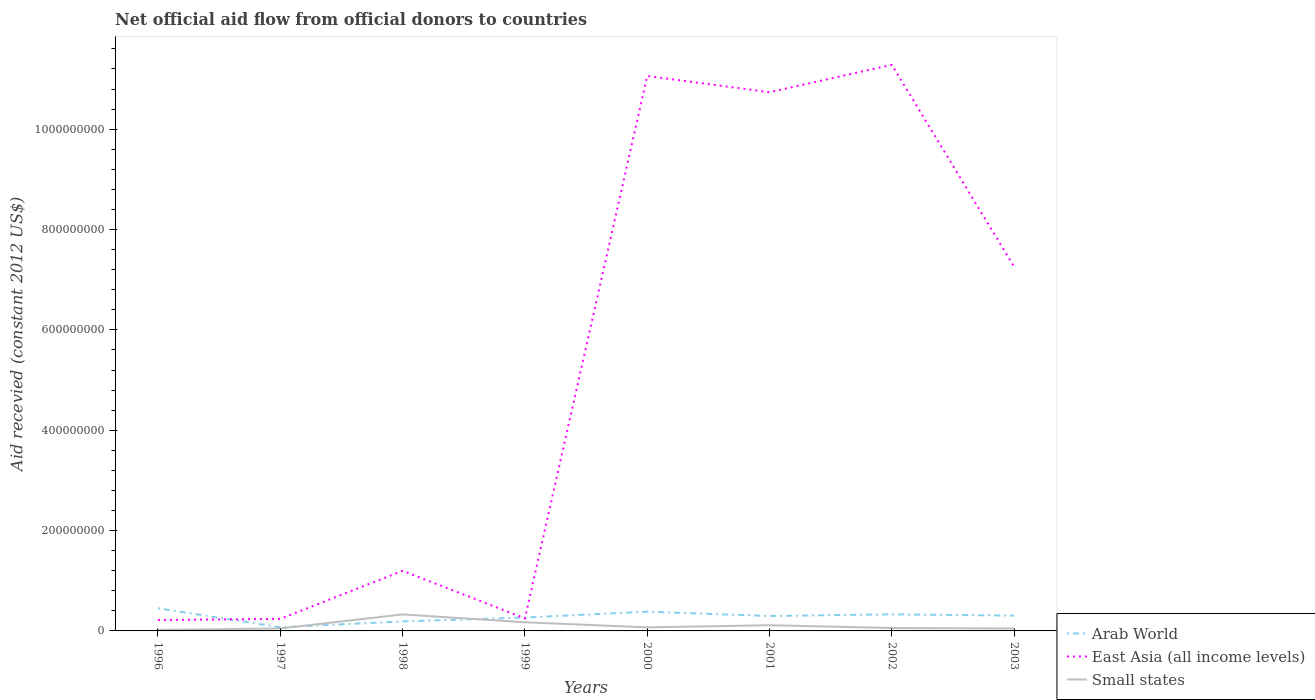How many different coloured lines are there?
Provide a short and direct response. 3. Is the number of lines equal to the number of legend labels?
Provide a short and direct response. Yes. Across all years, what is the maximum total aid received in Small states?
Provide a short and direct response. 2.04e+06. What is the total total aid received in Small states in the graph?
Provide a short and direct response. -2.89e+06. What is the difference between the highest and the second highest total aid received in Small states?
Your answer should be very brief. 3.09e+07. What is the difference between two consecutive major ticks on the Y-axis?
Your response must be concise. 2.00e+08. Are the values on the major ticks of Y-axis written in scientific E-notation?
Keep it short and to the point. No. Where does the legend appear in the graph?
Offer a very short reply. Bottom right. How many legend labels are there?
Offer a terse response. 3. How are the legend labels stacked?
Make the answer very short. Vertical. What is the title of the graph?
Make the answer very short. Net official aid flow from official donors to countries. What is the label or title of the Y-axis?
Provide a succinct answer. Aid recevied (constant 2012 US$). What is the Aid recevied (constant 2012 US$) in Arab World in 1996?
Provide a succinct answer. 4.51e+07. What is the Aid recevied (constant 2012 US$) in East Asia (all income levels) in 1996?
Provide a succinct answer. 2.17e+07. What is the Aid recevied (constant 2012 US$) of Small states in 1996?
Offer a very short reply. 2.04e+06. What is the Aid recevied (constant 2012 US$) of Arab World in 1997?
Offer a terse response. 7.29e+06. What is the Aid recevied (constant 2012 US$) in East Asia (all income levels) in 1997?
Provide a short and direct response. 2.41e+07. What is the Aid recevied (constant 2012 US$) of Small states in 1997?
Offer a terse response. 4.93e+06. What is the Aid recevied (constant 2012 US$) of Arab World in 1998?
Provide a short and direct response. 1.90e+07. What is the Aid recevied (constant 2012 US$) of East Asia (all income levels) in 1998?
Give a very brief answer. 1.20e+08. What is the Aid recevied (constant 2012 US$) in Small states in 1998?
Give a very brief answer. 3.29e+07. What is the Aid recevied (constant 2012 US$) of Arab World in 1999?
Your answer should be compact. 2.67e+07. What is the Aid recevied (constant 2012 US$) in East Asia (all income levels) in 1999?
Offer a terse response. 2.50e+07. What is the Aid recevied (constant 2012 US$) in Small states in 1999?
Provide a succinct answer. 1.72e+07. What is the Aid recevied (constant 2012 US$) of Arab World in 2000?
Offer a very short reply. 3.84e+07. What is the Aid recevied (constant 2012 US$) in East Asia (all income levels) in 2000?
Provide a succinct answer. 1.11e+09. What is the Aid recevied (constant 2012 US$) of Small states in 2000?
Make the answer very short. 7.08e+06. What is the Aid recevied (constant 2012 US$) in Arab World in 2001?
Your answer should be very brief. 2.97e+07. What is the Aid recevied (constant 2012 US$) in East Asia (all income levels) in 2001?
Your answer should be very brief. 1.07e+09. What is the Aid recevied (constant 2012 US$) of Small states in 2001?
Keep it short and to the point. 1.14e+07. What is the Aid recevied (constant 2012 US$) in Arab World in 2002?
Ensure brevity in your answer.  3.30e+07. What is the Aid recevied (constant 2012 US$) of East Asia (all income levels) in 2002?
Provide a short and direct response. 1.13e+09. What is the Aid recevied (constant 2012 US$) in Small states in 2002?
Provide a succinct answer. 5.78e+06. What is the Aid recevied (constant 2012 US$) in Arab World in 2003?
Ensure brevity in your answer.  3.05e+07. What is the Aid recevied (constant 2012 US$) in East Asia (all income levels) in 2003?
Keep it short and to the point. 7.26e+08. What is the Aid recevied (constant 2012 US$) in Small states in 2003?
Make the answer very short. 4.76e+06. Across all years, what is the maximum Aid recevied (constant 2012 US$) of Arab World?
Make the answer very short. 4.51e+07. Across all years, what is the maximum Aid recevied (constant 2012 US$) of East Asia (all income levels)?
Your response must be concise. 1.13e+09. Across all years, what is the maximum Aid recevied (constant 2012 US$) in Small states?
Give a very brief answer. 3.29e+07. Across all years, what is the minimum Aid recevied (constant 2012 US$) of Arab World?
Your answer should be compact. 7.29e+06. Across all years, what is the minimum Aid recevied (constant 2012 US$) in East Asia (all income levels)?
Your answer should be compact. 2.17e+07. Across all years, what is the minimum Aid recevied (constant 2012 US$) of Small states?
Keep it short and to the point. 2.04e+06. What is the total Aid recevied (constant 2012 US$) in Arab World in the graph?
Offer a very short reply. 2.30e+08. What is the total Aid recevied (constant 2012 US$) in East Asia (all income levels) in the graph?
Provide a succinct answer. 4.22e+09. What is the total Aid recevied (constant 2012 US$) in Small states in the graph?
Ensure brevity in your answer.  8.61e+07. What is the difference between the Aid recevied (constant 2012 US$) in Arab World in 1996 and that in 1997?
Offer a very short reply. 3.78e+07. What is the difference between the Aid recevied (constant 2012 US$) in East Asia (all income levels) in 1996 and that in 1997?
Your response must be concise. -2.39e+06. What is the difference between the Aid recevied (constant 2012 US$) of Small states in 1996 and that in 1997?
Provide a succinct answer. -2.89e+06. What is the difference between the Aid recevied (constant 2012 US$) in Arab World in 1996 and that in 1998?
Offer a terse response. 2.62e+07. What is the difference between the Aid recevied (constant 2012 US$) in East Asia (all income levels) in 1996 and that in 1998?
Offer a terse response. -9.81e+07. What is the difference between the Aid recevied (constant 2012 US$) in Small states in 1996 and that in 1998?
Give a very brief answer. -3.09e+07. What is the difference between the Aid recevied (constant 2012 US$) in Arab World in 1996 and that in 1999?
Offer a terse response. 1.85e+07. What is the difference between the Aid recevied (constant 2012 US$) of East Asia (all income levels) in 1996 and that in 1999?
Ensure brevity in your answer.  -3.34e+06. What is the difference between the Aid recevied (constant 2012 US$) in Small states in 1996 and that in 1999?
Your response must be concise. -1.52e+07. What is the difference between the Aid recevied (constant 2012 US$) in Arab World in 1996 and that in 2000?
Your answer should be very brief. 6.77e+06. What is the difference between the Aid recevied (constant 2012 US$) in East Asia (all income levels) in 1996 and that in 2000?
Your answer should be compact. -1.08e+09. What is the difference between the Aid recevied (constant 2012 US$) of Small states in 1996 and that in 2000?
Offer a terse response. -5.04e+06. What is the difference between the Aid recevied (constant 2012 US$) of Arab World in 1996 and that in 2001?
Provide a short and direct response. 1.54e+07. What is the difference between the Aid recevied (constant 2012 US$) of East Asia (all income levels) in 1996 and that in 2001?
Provide a succinct answer. -1.05e+09. What is the difference between the Aid recevied (constant 2012 US$) of Small states in 1996 and that in 2001?
Make the answer very short. -9.34e+06. What is the difference between the Aid recevied (constant 2012 US$) of Arab World in 1996 and that in 2002?
Make the answer very short. 1.21e+07. What is the difference between the Aid recevied (constant 2012 US$) of East Asia (all income levels) in 1996 and that in 2002?
Your response must be concise. -1.11e+09. What is the difference between the Aid recevied (constant 2012 US$) of Small states in 1996 and that in 2002?
Your answer should be compact. -3.74e+06. What is the difference between the Aid recevied (constant 2012 US$) in Arab World in 1996 and that in 2003?
Your answer should be compact. 1.46e+07. What is the difference between the Aid recevied (constant 2012 US$) in East Asia (all income levels) in 1996 and that in 2003?
Provide a short and direct response. -7.04e+08. What is the difference between the Aid recevied (constant 2012 US$) of Small states in 1996 and that in 2003?
Make the answer very short. -2.72e+06. What is the difference between the Aid recevied (constant 2012 US$) of Arab World in 1997 and that in 1998?
Offer a very short reply. -1.17e+07. What is the difference between the Aid recevied (constant 2012 US$) in East Asia (all income levels) in 1997 and that in 1998?
Make the answer very short. -9.57e+07. What is the difference between the Aid recevied (constant 2012 US$) in Small states in 1997 and that in 1998?
Keep it short and to the point. -2.80e+07. What is the difference between the Aid recevied (constant 2012 US$) of Arab World in 1997 and that in 1999?
Give a very brief answer. -1.94e+07. What is the difference between the Aid recevied (constant 2012 US$) in East Asia (all income levels) in 1997 and that in 1999?
Provide a succinct answer. -9.50e+05. What is the difference between the Aid recevied (constant 2012 US$) of Small states in 1997 and that in 1999?
Your answer should be very brief. -1.23e+07. What is the difference between the Aid recevied (constant 2012 US$) of Arab World in 1997 and that in 2000?
Keep it short and to the point. -3.11e+07. What is the difference between the Aid recevied (constant 2012 US$) of East Asia (all income levels) in 1997 and that in 2000?
Offer a terse response. -1.08e+09. What is the difference between the Aid recevied (constant 2012 US$) in Small states in 1997 and that in 2000?
Provide a succinct answer. -2.15e+06. What is the difference between the Aid recevied (constant 2012 US$) in Arab World in 1997 and that in 2001?
Offer a terse response. -2.24e+07. What is the difference between the Aid recevied (constant 2012 US$) in East Asia (all income levels) in 1997 and that in 2001?
Ensure brevity in your answer.  -1.05e+09. What is the difference between the Aid recevied (constant 2012 US$) of Small states in 1997 and that in 2001?
Offer a terse response. -6.45e+06. What is the difference between the Aid recevied (constant 2012 US$) of Arab World in 1997 and that in 2002?
Ensure brevity in your answer.  -2.58e+07. What is the difference between the Aid recevied (constant 2012 US$) in East Asia (all income levels) in 1997 and that in 2002?
Provide a succinct answer. -1.10e+09. What is the difference between the Aid recevied (constant 2012 US$) of Small states in 1997 and that in 2002?
Provide a succinct answer. -8.50e+05. What is the difference between the Aid recevied (constant 2012 US$) in Arab World in 1997 and that in 2003?
Ensure brevity in your answer.  -2.32e+07. What is the difference between the Aid recevied (constant 2012 US$) in East Asia (all income levels) in 1997 and that in 2003?
Offer a terse response. -7.02e+08. What is the difference between the Aid recevied (constant 2012 US$) in Arab World in 1998 and that in 1999?
Provide a short and direct response. -7.71e+06. What is the difference between the Aid recevied (constant 2012 US$) in East Asia (all income levels) in 1998 and that in 1999?
Provide a short and direct response. 9.48e+07. What is the difference between the Aid recevied (constant 2012 US$) in Small states in 1998 and that in 1999?
Offer a terse response. 1.57e+07. What is the difference between the Aid recevied (constant 2012 US$) in Arab World in 1998 and that in 2000?
Make the answer very short. -1.94e+07. What is the difference between the Aid recevied (constant 2012 US$) of East Asia (all income levels) in 1998 and that in 2000?
Provide a short and direct response. -9.86e+08. What is the difference between the Aid recevied (constant 2012 US$) of Small states in 1998 and that in 2000?
Your response must be concise. 2.58e+07. What is the difference between the Aid recevied (constant 2012 US$) of Arab World in 1998 and that in 2001?
Provide a short and direct response. -1.07e+07. What is the difference between the Aid recevied (constant 2012 US$) of East Asia (all income levels) in 1998 and that in 2001?
Give a very brief answer. -9.54e+08. What is the difference between the Aid recevied (constant 2012 US$) of Small states in 1998 and that in 2001?
Keep it short and to the point. 2.15e+07. What is the difference between the Aid recevied (constant 2012 US$) of Arab World in 1998 and that in 2002?
Provide a short and direct response. -1.41e+07. What is the difference between the Aid recevied (constant 2012 US$) of East Asia (all income levels) in 1998 and that in 2002?
Provide a succinct answer. -1.01e+09. What is the difference between the Aid recevied (constant 2012 US$) in Small states in 1998 and that in 2002?
Your answer should be very brief. 2.71e+07. What is the difference between the Aid recevied (constant 2012 US$) of Arab World in 1998 and that in 2003?
Make the answer very short. -1.15e+07. What is the difference between the Aid recevied (constant 2012 US$) of East Asia (all income levels) in 1998 and that in 2003?
Offer a very short reply. -6.06e+08. What is the difference between the Aid recevied (constant 2012 US$) of Small states in 1998 and that in 2003?
Your response must be concise. 2.81e+07. What is the difference between the Aid recevied (constant 2012 US$) of Arab World in 1999 and that in 2000?
Offer a very short reply. -1.17e+07. What is the difference between the Aid recevied (constant 2012 US$) in East Asia (all income levels) in 1999 and that in 2000?
Your response must be concise. -1.08e+09. What is the difference between the Aid recevied (constant 2012 US$) of Small states in 1999 and that in 2000?
Offer a very short reply. 1.02e+07. What is the difference between the Aid recevied (constant 2012 US$) in Arab World in 1999 and that in 2001?
Make the answer very short. -3.03e+06. What is the difference between the Aid recevied (constant 2012 US$) of East Asia (all income levels) in 1999 and that in 2001?
Provide a short and direct response. -1.05e+09. What is the difference between the Aid recevied (constant 2012 US$) in Small states in 1999 and that in 2001?
Give a very brief answer. 5.86e+06. What is the difference between the Aid recevied (constant 2012 US$) in Arab World in 1999 and that in 2002?
Make the answer very short. -6.38e+06. What is the difference between the Aid recevied (constant 2012 US$) in East Asia (all income levels) in 1999 and that in 2002?
Offer a terse response. -1.10e+09. What is the difference between the Aid recevied (constant 2012 US$) of Small states in 1999 and that in 2002?
Provide a short and direct response. 1.15e+07. What is the difference between the Aid recevied (constant 2012 US$) of Arab World in 1999 and that in 2003?
Your answer should be very brief. -3.83e+06. What is the difference between the Aid recevied (constant 2012 US$) in East Asia (all income levels) in 1999 and that in 2003?
Provide a succinct answer. -7.01e+08. What is the difference between the Aid recevied (constant 2012 US$) of Small states in 1999 and that in 2003?
Keep it short and to the point. 1.25e+07. What is the difference between the Aid recevied (constant 2012 US$) in Arab World in 2000 and that in 2001?
Give a very brief answer. 8.66e+06. What is the difference between the Aid recevied (constant 2012 US$) in East Asia (all income levels) in 2000 and that in 2001?
Make the answer very short. 3.23e+07. What is the difference between the Aid recevied (constant 2012 US$) in Small states in 2000 and that in 2001?
Your response must be concise. -4.30e+06. What is the difference between the Aid recevied (constant 2012 US$) in Arab World in 2000 and that in 2002?
Your answer should be compact. 5.31e+06. What is the difference between the Aid recevied (constant 2012 US$) in East Asia (all income levels) in 2000 and that in 2002?
Give a very brief answer. -2.23e+07. What is the difference between the Aid recevied (constant 2012 US$) in Small states in 2000 and that in 2002?
Offer a terse response. 1.30e+06. What is the difference between the Aid recevied (constant 2012 US$) in Arab World in 2000 and that in 2003?
Your response must be concise. 7.86e+06. What is the difference between the Aid recevied (constant 2012 US$) of East Asia (all income levels) in 2000 and that in 2003?
Make the answer very short. 3.80e+08. What is the difference between the Aid recevied (constant 2012 US$) of Small states in 2000 and that in 2003?
Provide a succinct answer. 2.32e+06. What is the difference between the Aid recevied (constant 2012 US$) in Arab World in 2001 and that in 2002?
Offer a very short reply. -3.35e+06. What is the difference between the Aid recevied (constant 2012 US$) in East Asia (all income levels) in 2001 and that in 2002?
Provide a succinct answer. -5.46e+07. What is the difference between the Aid recevied (constant 2012 US$) in Small states in 2001 and that in 2002?
Your answer should be compact. 5.60e+06. What is the difference between the Aid recevied (constant 2012 US$) in Arab World in 2001 and that in 2003?
Give a very brief answer. -8.00e+05. What is the difference between the Aid recevied (constant 2012 US$) in East Asia (all income levels) in 2001 and that in 2003?
Offer a very short reply. 3.48e+08. What is the difference between the Aid recevied (constant 2012 US$) in Small states in 2001 and that in 2003?
Keep it short and to the point. 6.62e+06. What is the difference between the Aid recevied (constant 2012 US$) in Arab World in 2002 and that in 2003?
Keep it short and to the point. 2.55e+06. What is the difference between the Aid recevied (constant 2012 US$) of East Asia (all income levels) in 2002 and that in 2003?
Keep it short and to the point. 4.02e+08. What is the difference between the Aid recevied (constant 2012 US$) in Small states in 2002 and that in 2003?
Your response must be concise. 1.02e+06. What is the difference between the Aid recevied (constant 2012 US$) of Arab World in 1996 and the Aid recevied (constant 2012 US$) of East Asia (all income levels) in 1997?
Your answer should be very brief. 2.10e+07. What is the difference between the Aid recevied (constant 2012 US$) in Arab World in 1996 and the Aid recevied (constant 2012 US$) in Small states in 1997?
Offer a very short reply. 4.02e+07. What is the difference between the Aid recevied (constant 2012 US$) in East Asia (all income levels) in 1996 and the Aid recevied (constant 2012 US$) in Small states in 1997?
Your answer should be very brief. 1.68e+07. What is the difference between the Aid recevied (constant 2012 US$) in Arab World in 1996 and the Aid recevied (constant 2012 US$) in East Asia (all income levels) in 1998?
Offer a terse response. -7.46e+07. What is the difference between the Aid recevied (constant 2012 US$) of Arab World in 1996 and the Aid recevied (constant 2012 US$) of Small states in 1998?
Ensure brevity in your answer.  1.22e+07. What is the difference between the Aid recevied (constant 2012 US$) in East Asia (all income levels) in 1996 and the Aid recevied (constant 2012 US$) in Small states in 1998?
Offer a very short reply. -1.12e+07. What is the difference between the Aid recevied (constant 2012 US$) of Arab World in 1996 and the Aid recevied (constant 2012 US$) of East Asia (all income levels) in 1999?
Your answer should be compact. 2.01e+07. What is the difference between the Aid recevied (constant 2012 US$) of Arab World in 1996 and the Aid recevied (constant 2012 US$) of Small states in 1999?
Give a very brief answer. 2.79e+07. What is the difference between the Aid recevied (constant 2012 US$) of East Asia (all income levels) in 1996 and the Aid recevied (constant 2012 US$) of Small states in 1999?
Your response must be concise. 4.45e+06. What is the difference between the Aid recevied (constant 2012 US$) in Arab World in 1996 and the Aid recevied (constant 2012 US$) in East Asia (all income levels) in 2000?
Keep it short and to the point. -1.06e+09. What is the difference between the Aid recevied (constant 2012 US$) of Arab World in 1996 and the Aid recevied (constant 2012 US$) of Small states in 2000?
Ensure brevity in your answer.  3.80e+07. What is the difference between the Aid recevied (constant 2012 US$) in East Asia (all income levels) in 1996 and the Aid recevied (constant 2012 US$) in Small states in 2000?
Make the answer very short. 1.46e+07. What is the difference between the Aid recevied (constant 2012 US$) of Arab World in 1996 and the Aid recevied (constant 2012 US$) of East Asia (all income levels) in 2001?
Ensure brevity in your answer.  -1.03e+09. What is the difference between the Aid recevied (constant 2012 US$) in Arab World in 1996 and the Aid recevied (constant 2012 US$) in Small states in 2001?
Give a very brief answer. 3.38e+07. What is the difference between the Aid recevied (constant 2012 US$) in East Asia (all income levels) in 1996 and the Aid recevied (constant 2012 US$) in Small states in 2001?
Your answer should be compact. 1.03e+07. What is the difference between the Aid recevied (constant 2012 US$) in Arab World in 1996 and the Aid recevied (constant 2012 US$) in East Asia (all income levels) in 2002?
Keep it short and to the point. -1.08e+09. What is the difference between the Aid recevied (constant 2012 US$) in Arab World in 1996 and the Aid recevied (constant 2012 US$) in Small states in 2002?
Your answer should be very brief. 3.94e+07. What is the difference between the Aid recevied (constant 2012 US$) of East Asia (all income levels) in 1996 and the Aid recevied (constant 2012 US$) of Small states in 2002?
Give a very brief answer. 1.59e+07. What is the difference between the Aid recevied (constant 2012 US$) of Arab World in 1996 and the Aid recevied (constant 2012 US$) of East Asia (all income levels) in 2003?
Ensure brevity in your answer.  -6.81e+08. What is the difference between the Aid recevied (constant 2012 US$) in Arab World in 1996 and the Aid recevied (constant 2012 US$) in Small states in 2003?
Keep it short and to the point. 4.04e+07. What is the difference between the Aid recevied (constant 2012 US$) in East Asia (all income levels) in 1996 and the Aid recevied (constant 2012 US$) in Small states in 2003?
Your answer should be compact. 1.69e+07. What is the difference between the Aid recevied (constant 2012 US$) in Arab World in 1997 and the Aid recevied (constant 2012 US$) in East Asia (all income levels) in 1998?
Your answer should be very brief. -1.12e+08. What is the difference between the Aid recevied (constant 2012 US$) in Arab World in 1997 and the Aid recevied (constant 2012 US$) in Small states in 1998?
Your response must be concise. -2.56e+07. What is the difference between the Aid recevied (constant 2012 US$) of East Asia (all income levels) in 1997 and the Aid recevied (constant 2012 US$) of Small states in 1998?
Provide a short and direct response. -8.82e+06. What is the difference between the Aid recevied (constant 2012 US$) of Arab World in 1997 and the Aid recevied (constant 2012 US$) of East Asia (all income levels) in 1999?
Keep it short and to the point. -1.77e+07. What is the difference between the Aid recevied (constant 2012 US$) of Arab World in 1997 and the Aid recevied (constant 2012 US$) of Small states in 1999?
Your answer should be compact. -9.95e+06. What is the difference between the Aid recevied (constant 2012 US$) in East Asia (all income levels) in 1997 and the Aid recevied (constant 2012 US$) in Small states in 1999?
Ensure brevity in your answer.  6.84e+06. What is the difference between the Aid recevied (constant 2012 US$) in Arab World in 1997 and the Aid recevied (constant 2012 US$) in East Asia (all income levels) in 2000?
Provide a succinct answer. -1.10e+09. What is the difference between the Aid recevied (constant 2012 US$) in East Asia (all income levels) in 1997 and the Aid recevied (constant 2012 US$) in Small states in 2000?
Your answer should be compact. 1.70e+07. What is the difference between the Aid recevied (constant 2012 US$) in Arab World in 1997 and the Aid recevied (constant 2012 US$) in East Asia (all income levels) in 2001?
Your answer should be very brief. -1.07e+09. What is the difference between the Aid recevied (constant 2012 US$) in Arab World in 1997 and the Aid recevied (constant 2012 US$) in Small states in 2001?
Your answer should be very brief. -4.09e+06. What is the difference between the Aid recevied (constant 2012 US$) in East Asia (all income levels) in 1997 and the Aid recevied (constant 2012 US$) in Small states in 2001?
Your answer should be very brief. 1.27e+07. What is the difference between the Aid recevied (constant 2012 US$) of Arab World in 1997 and the Aid recevied (constant 2012 US$) of East Asia (all income levels) in 2002?
Offer a very short reply. -1.12e+09. What is the difference between the Aid recevied (constant 2012 US$) of Arab World in 1997 and the Aid recevied (constant 2012 US$) of Small states in 2002?
Your answer should be compact. 1.51e+06. What is the difference between the Aid recevied (constant 2012 US$) in East Asia (all income levels) in 1997 and the Aid recevied (constant 2012 US$) in Small states in 2002?
Provide a short and direct response. 1.83e+07. What is the difference between the Aid recevied (constant 2012 US$) in Arab World in 1997 and the Aid recevied (constant 2012 US$) in East Asia (all income levels) in 2003?
Keep it short and to the point. -7.18e+08. What is the difference between the Aid recevied (constant 2012 US$) in Arab World in 1997 and the Aid recevied (constant 2012 US$) in Small states in 2003?
Your response must be concise. 2.53e+06. What is the difference between the Aid recevied (constant 2012 US$) in East Asia (all income levels) in 1997 and the Aid recevied (constant 2012 US$) in Small states in 2003?
Provide a succinct answer. 1.93e+07. What is the difference between the Aid recevied (constant 2012 US$) in Arab World in 1998 and the Aid recevied (constant 2012 US$) in East Asia (all income levels) in 1999?
Offer a very short reply. -6.07e+06. What is the difference between the Aid recevied (constant 2012 US$) in Arab World in 1998 and the Aid recevied (constant 2012 US$) in Small states in 1999?
Give a very brief answer. 1.72e+06. What is the difference between the Aid recevied (constant 2012 US$) in East Asia (all income levels) in 1998 and the Aid recevied (constant 2012 US$) in Small states in 1999?
Give a very brief answer. 1.03e+08. What is the difference between the Aid recevied (constant 2012 US$) of Arab World in 1998 and the Aid recevied (constant 2012 US$) of East Asia (all income levels) in 2000?
Offer a very short reply. -1.09e+09. What is the difference between the Aid recevied (constant 2012 US$) in Arab World in 1998 and the Aid recevied (constant 2012 US$) in Small states in 2000?
Your answer should be compact. 1.19e+07. What is the difference between the Aid recevied (constant 2012 US$) in East Asia (all income levels) in 1998 and the Aid recevied (constant 2012 US$) in Small states in 2000?
Offer a very short reply. 1.13e+08. What is the difference between the Aid recevied (constant 2012 US$) in Arab World in 1998 and the Aid recevied (constant 2012 US$) in East Asia (all income levels) in 2001?
Make the answer very short. -1.05e+09. What is the difference between the Aid recevied (constant 2012 US$) of Arab World in 1998 and the Aid recevied (constant 2012 US$) of Small states in 2001?
Your answer should be compact. 7.58e+06. What is the difference between the Aid recevied (constant 2012 US$) in East Asia (all income levels) in 1998 and the Aid recevied (constant 2012 US$) in Small states in 2001?
Offer a very short reply. 1.08e+08. What is the difference between the Aid recevied (constant 2012 US$) of Arab World in 1998 and the Aid recevied (constant 2012 US$) of East Asia (all income levels) in 2002?
Make the answer very short. -1.11e+09. What is the difference between the Aid recevied (constant 2012 US$) in Arab World in 1998 and the Aid recevied (constant 2012 US$) in Small states in 2002?
Ensure brevity in your answer.  1.32e+07. What is the difference between the Aid recevied (constant 2012 US$) of East Asia (all income levels) in 1998 and the Aid recevied (constant 2012 US$) of Small states in 2002?
Ensure brevity in your answer.  1.14e+08. What is the difference between the Aid recevied (constant 2012 US$) of Arab World in 1998 and the Aid recevied (constant 2012 US$) of East Asia (all income levels) in 2003?
Your answer should be very brief. -7.07e+08. What is the difference between the Aid recevied (constant 2012 US$) in Arab World in 1998 and the Aid recevied (constant 2012 US$) in Small states in 2003?
Make the answer very short. 1.42e+07. What is the difference between the Aid recevied (constant 2012 US$) in East Asia (all income levels) in 1998 and the Aid recevied (constant 2012 US$) in Small states in 2003?
Provide a succinct answer. 1.15e+08. What is the difference between the Aid recevied (constant 2012 US$) of Arab World in 1999 and the Aid recevied (constant 2012 US$) of East Asia (all income levels) in 2000?
Make the answer very short. -1.08e+09. What is the difference between the Aid recevied (constant 2012 US$) in Arab World in 1999 and the Aid recevied (constant 2012 US$) in Small states in 2000?
Keep it short and to the point. 1.96e+07. What is the difference between the Aid recevied (constant 2012 US$) in East Asia (all income levels) in 1999 and the Aid recevied (constant 2012 US$) in Small states in 2000?
Provide a succinct answer. 1.80e+07. What is the difference between the Aid recevied (constant 2012 US$) in Arab World in 1999 and the Aid recevied (constant 2012 US$) in East Asia (all income levels) in 2001?
Provide a succinct answer. -1.05e+09. What is the difference between the Aid recevied (constant 2012 US$) of Arab World in 1999 and the Aid recevied (constant 2012 US$) of Small states in 2001?
Provide a short and direct response. 1.53e+07. What is the difference between the Aid recevied (constant 2012 US$) in East Asia (all income levels) in 1999 and the Aid recevied (constant 2012 US$) in Small states in 2001?
Ensure brevity in your answer.  1.36e+07. What is the difference between the Aid recevied (constant 2012 US$) in Arab World in 1999 and the Aid recevied (constant 2012 US$) in East Asia (all income levels) in 2002?
Ensure brevity in your answer.  -1.10e+09. What is the difference between the Aid recevied (constant 2012 US$) of Arab World in 1999 and the Aid recevied (constant 2012 US$) of Small states in 2002?
Keep it short and to the point. 2.09e+07. What is the difference between the Aid recevied (constant 2012 US$) of East Asia (all income levels) in 1999 and the Aid recevied (constant 2012 US$) of Small states in 2002?
Offer a very short reply. 1.92e+07. What is the difference between the Aid recevied (constant 2012 US$) in Arab World in 1999 and the Aid recevied (constant 2012 US$) in East Asia (all income levels) in 2003?
Make the answer very short. -6.99e+08. What is the difference between the Aid recevied (constant 2012 US$) of Arab World in 1999 and the Aid recevied (constant 2012 US$) of Small states in 2003?
Provide a succinct answer. 2.19e+07. What is the difference between the Aid recevied (constant 2012 US$) in East Asia (all income levels) in 1999 and the Aid recevied (constant 2012 US$) in Small states in 2003?
Provide a succinct answer. 2.03e+07. What is the difference between the Aid recevied (constant 2012 US$) of Arab World in 2000 and the Aid recevied (constant 2012 US$) of East Asia (all income levels) in 2001?
Your answer should be very brief. -1.04e+09. What is the difference between the Aid recevied (constant 2012 US$) of Arab World in 2000 and the Aid recevied (constant 2012 US$) of Small states in 2001?
Provide a succinct answer. 2.70e+07. What is the difference between the Aid recevied (constant 2012 US$) of East Asia (all income levels) in 2000 and the Aid recevied (constant 2012 US$) of Small states in 2001?
Keep it short and to the point. 1.09e+09. What is the difference between the Aid recevied (constant 2012 US$) of Arab World in 2000 and the Aid recevied (constant 2012 US$) of East Asia (all income levels) in 2002?
Make the answer very short. -1.09e+09. What is the difference between the Aid recevied (constant 2012 US$) in Arab World in 2000 and the Aid recevied (constant 2012 US$) in Small states in 2002?
Your answer should be compact. 3.26e+07. What is the difference between the Aid recevied (constant 2012 US$) in East Asia (all income levels) in 2000 and the Aid recevied (constant 2012 US$) in Small states in 2002?
Keep it short and to the point. 1.10e+09. What is the difference between the Aid recevied (constant 2012 US$) of Arab World in 2000 and the Aid recevied (constant 2012 US$) of East Asia (all income levels) in 2003?
Provide a succinct answer. -6.87e+08. What is the difference between the Aid recevied (constant 2012 US$) in Arab World in 2000 and the Aid recevied (constant 2012 US$) in Small states in 2003?
Give a very brief answer. 3.36e+07. What is the difference between the Aid recevied (constant 2012 US$) of East Asia (all income levels) in 2000 and the Aid recevied (constant 2012 US$) of Small states in 2003?
Provide a short and direct response. 1.10e+09. What is the difference between the Aid recevied (constant 2012 US$) of Arab World in 2001 and the Aid recevied (constant 2012 US$) of East Asia (all income levels) in 2002?
Provide a short and direct response. -1.10e+09. What is the difference between the Aid recevied (constant 2012 US$) of Arab World in 2001 and the Aid recevied (constant 2012 US$) of Small states in 2002?
Keep it short and to the point. 2.39e+07. What is the difference between the Aid recevied (constant 2012 US$) in East Asia (all income levels) in 2001 and the Aid recevied (constant 2012 US$) in Small states in 2002?
Your response must be concise. 1.07e+09. What is the difference between the Aid recevied (constant 2012 US$) of Arab World in 2001 and the Aid recevied (constant 2012 US$) of East Asia (all income levels) in 2003?
Your answer should be compact. -6.96e+08. What is the difference between the Aid recevied (constant 2012 US$) in Arab World in 2001 and the Aid recevied (constant 2012 US$) in Small states in 2003?
Provide a short and direct response. 2.49e+07. What is the difference between the Aid recevied (constant 2012 US$) of East Asia (all income levels) in 2001 and the Aid recevied (constant 2012 US$) of Small states in 2003?
Your answer should be very brief. 1.07e+09. What is the difference between the Aid recevied (constant 2012 US$) in Arab World in 2002 and the Aid recevied (constant 2012 US$) in East Asia (all income levels) in 2003?
Provide a succinct answer. -6.93e+08. What is the difference between the Aid recevied (constant 2012 US$) of Arab World in 2002 and the Aid recevied (constant 2012 US$) of Small states in 2003?
Your response must be concise. 2.83e+07. What is the difference between the Aid recevied (constant 2012 US$) in East Asia (all income levels) in 2002 and the Aid recevied (constant 2012 US$) in Small states in 2003?
Your answer should be compact. 1.12e+09. What is the average Aid recevied (constant 2012 US$) of Arab World per year?
Your answer should be compact. 2.87e+07. What is the average Aid recevied (constant 2012 US$) of East Asia (all income levels) per year?
Keep it short and to the point. 5.28e+08. What is the average Aid recevied (constant 2012 US$) of Small states per year?
Offer a very short reply. 1.08e+07. In the year 1996, what is the difference between the Aid recevied (constant 2012 US$) of Arab World and Aid recevied (constant 2012 US$) of East Asia (all income levels)?
Give a very brief answer. 2.34e+07. In the year 1996, what is the difference between the Aid recevied (constant 2012 US$) of Arab World and Aid recevied (constant 2012 US$) of Small states?
Offer a terse response. 4.31e+07. In the year 1996, what is the difference between the Aid recevied (constant 2012 US$) of East Asia (all income levels) and Aid recevied (constant 2012 US$) of Small states?
Provide a succinct answer. 1.96e+07. In the year 1997, what is the difference between the Aid recevied (constant 2012 US$) of Arab World and Aid recevied (constant 2012 US$) of East Asia (all income levels)?
Provide a short and direct response. -1.68e+07. In the year 1997, what is the difference between the Aid recevied (constant 2012 US$) in Arab World and Aid recevied (constant 2012 US$) in Small states?
Make the answer very short. 2.36e+06. In the year 1997, what is the difference between the Aid recevied (constant 2012 US$) of East Asia (all income levels) and Aid recevied (constant 2012 US$) of Small states?
Keep it short and to the point. 1.92e+07. In the year 1998, what is the difference between the Aid recevied (constant 2012 US$) in Arab World and Aid recevied (constant 2012 US$) in East Asia (all income levels)?
Your answer should be compact. -1.01e+08. In the year 1998, what is the difference between the Aid recevied (constant 2012 US$) of Arab World and Aid recevied (constant 2012 US$) of Small states?
Your answer should be very brief. -1.39e+07. In the year 1998, what is the difference between the Aid recevied (constant 2012 US$) of East Asia (all income levels) and Aid recevied (constant 2012 US$) of Small states?
Provide a succinct answer. 8.69e+07. In the year 1999, what is the difference between the Aid recevied (constant 2012 US$) of Arab World and Aid recevied (constant 2012 US$) of East Asia (all income levels)?
Offer a terse response. 1.64e+06. In the year 1999, what is the difference between the Aid recevied (constant 2012 US$) of Arab World and Aid recevied (constant 2012 US$) of Small states?
Your response must be concise. 9.43e+06. In the year 1999, what is the difference between the Aid recevied (constant 2012 US$) in East Asia (all income levels) and Aid recevied (constant 2012 US$) in Small states?
Give a very brief answer. 7.79e+06. In the year 2000, what is the difference between the Aid recevied (constant 2012 US$) of Arab World and Aid recevied (constant 2012 US$) of East Asia (all income levels)?
Offer a very short reply. -1.07e+09. In the year 2000, what is the difference between the Aid recevied (constant 2012 US$) of Arab World and Aid recevied (constant 2012 US$) of Small states?
Your response must be concise. 3.13e+07. In the year 2000, what is the difference between the Aid recevied (constant 2012 US$) of East Asia (all income levels) and Aid recevied (constant 2012 US$) of Small states?
Ensure brevity in your answer.  1.10e+09. In the year 2001, what is the difference between the Aid recevied (constant 2012 US$) of Arab World and Aid recevied (constant 2012 US$) of East Asia (all income levels)?
Keep it short and to the point. -1.04e+09. In the year 2001, what is the difference between the Aid recevied (constant 2012 US$) in Arab World and Aid recevied (constant 2012 US$) in Small states?
Provide a succinct answer. 1.83e+07. In the year 2001, what is the difference between the Aid recevied (constant 2012 US$) of East Asia (all income levels) and Aid recevied (constant 2012 US$) of Small states?
Offer a terse response. 1.06e+09. In the year 2002, what is the difference between the Aid recevied (constant 2012 US$) in Arab World and Aid recevied (constant 2012 US$) in East Asia (all income levels)?
Ensure brevity in your answer.  -1.10e+09. In the year 2002, what is the difference between the Aid recevied (constant 2012 US$) in Arab World and Aid recevied (constant 2012 US$) in Small states?
Offer a very short reply. 2.73e+07. In the year 2002, what is the difference between the Aid recevied (constant 2012 US$) in East Asia (all income levels) and Aid recevied (constant 2012 US$) in Small states?
Offer a very short reply. 1.12e+09. In the year 2003, what is the difference between the Aid recevied (constant 2012 US$) of Arab World and Aid recevied (constant 2012 US$) of East Asia (all income levels)?
Make the answer very short. -6.95e+08. In the year 2003, what is the difference between the Aid recevied (constant 2012 US$) in Arab World and Aid recevied (constant 2012 US$) in Small states?
Provide a short and direct response. 2.57e+07. In the year 2003, what is the difference between the Aid recevied (constant 2012 US$) of East Asia (all income levels) and Aid recevied (constant 2012 US$) of Small states?
Ensure brevity in your answer.  7.21e+08. What is the ratio of the Aid recevied (constant 2012 US$) of Arab World in 1996 to that in 1997?
Your answer should be very brief. 6.19. What is the ratio of the Aid recevied (constant 2012 US$) of East Asia (all income levels) in 1996 to that in 1997?
Your answer should be very brief. 0.9. What is the ratio of the Aid recevied (constant 2012 US$) of Small states in 1996 to that in 1997?
Offer a terse response. 0.41. What is the ratio of the Aid recevied (constant 2012 US$) in Arab World in 1996 to that in 1998?
Offer a very short reply. 2.38. What is the ratio of the Aid recevied (constant 2012 US$) in East Asia (all income levels) in 1996 to that in 1998?
Provide a succinct answer. 0.18. What is the ratio of the Aid recevied (constant 2012 US$) in Small states in 1996 to that in 1998?
Offer a terse response. 0.06. What is the ratio of the Aid recevied (constant 2012 US$) of Arab World in 1996 to that in 1999?
Keep it short and to the point. 1.69. What is the ratio of the Aid recevied (constant 2012 US$) in East Asia (all income levels) in 1996 to that in 1999?
Give a very brief answer. 0.87. What is the ratio of the Aid recevied (constant 2012 US$) in Small states in 1996 to that in 1999?
Give a very brief answer. 0.12. What is the ratio of the Aid recevied (constant 2012 US$) of Arab World in 1996 to that in 2000?
Your answer should be compact. 1.18. What is the ratio of the Aid recevied (constant 2012 US$) of East Asia (all income levels) in 1996 to that in 2000?
Ensure brevity in your answer.  0.02. What is the ratio of the Aid recevied (constant 2012 US$) of Small states in 1996 to that in 2000?
Your answer should be very brief. 0.29. What is the ratio of the Aid recevied (constant 2012 US$) in Arab World in 1996 to that in 2001?
Your response must be concise. 1.52. What is the ratio of the Aid recevied (constant 2012 US$) of East Asia (all income levels) in 1996 to that in 2001?
Offer a very short reply. 0.02. What is the ratio of the Aid recevied (constant 2012 US$) in Small states in 1996 to that in 2001?
Your answer should be very brief. 0.18. What is the ratio of the Aid recevied (constant 2012 US$) of Arab World in 1996 to that in 2002?
Your answer should be very brief. 1.37. What is the ratio of the Aid recevied (constant 2012 US$) of East Asia (all income levels) in 1996 to that in 2002?
Give a very brief answer. 0.02. What is the ratio of the Aid recevied (constant 2012 US$) of Small states in 1996 to that in 2002?
Provide a succinct answer. 0.35. What is the ratio of the Aid recevied (constant 2012 US$) in Arab World in 1996 to that in 2003?
Make the answer very short. 1.48. What is the ratio of the Aid recevied (constant 2012 US$) of East Asia (all income levels) in 1996 to that in 2003?
Keep it short and to the point. 0.03. What is the ratio of the Aid recevied (constant 2012 US$) in Small states in 1996 to that in 2003?
Your answer should be compact. 0.43. What is the ratio of the Aid recevied (constant 2012 US$) in Arab World in 1997 to that in 1998?
Ensure brevity in your answer.  0.38. What is the ratio of the Aid recevied (constant 2012 US$) in East Asia (all income levels) in 1997 to that in 1998?
Your response must be concise. 0.2. What is the ratio of the Aid recevied (constant 2012 US$) of Small states in 1997 to that in 1998?
Provide a short and direct response. 0.15. What is the ratio of the Aid recevied (constant 2012 US$) of Arab World in 1997 to that in 1999?
Your response must be concise. 0.27. What is the ratio of the Aid recevied (constant 2012 US$) in Small states in 1997 to that in 1999?
Offer a terse response. 0.29. What is the ratio of the Aid recevied (constant 2012 US$) in Arab World in 1997 to that in 2000?
Give a very brief answer. 0.19. What is the ratio of the Aid recevied (constant 2012 US$) of East Asia (all income levels) in 1997 to that in 2000?
Offer a terse response. 0.02. What is the ratio of the Aid recevied (constant 2012 US$) in Small states in 1997 to that in 2000?
Make the answer very short. 0.7. What is the ratio of the Aid recevied (constant 2012 US$) of Arab World in 1997 to that in 2001?
Your answer should be very brief. 0.25. What is the ratio of the Aid recevied (constant 2012 US$) of East Asia (all income levels) in 1997 to that in 2001?
Your response must be concise. 0.02. What is the ratio of the Aid recevied (constant 2012 US$) in Small states in 1997 to that in 2001?
Offer a terse response. 0.43. What is the ratio of the Aid recevied (constant 2012 US$) in Arab World in 1997 to that in 2002?
Give a very brief answer. 0.22. What is the ratio of the Aid recevied (constant 2012 US$) in East Asia (all income levels) in 1997 to that in 2002?
Ensure brevity in your answer.  0.02. What is the ratio of the Aid recevied (constant 2012 US$) of Small states in 1997 to that in 2002?
Your answer should be compact. 0.85. What is the ratio of the Aid recevied (constant 2012 US$) in Arab World in 1997 to that in 2003?
Provide a short and direct response. 0.24. What is the ratio of the Aid recevied (constant 2012 US$) in East Asia (all income levels) in 1997 to that in 2003?
Your answer should be very brief. 0.03. What is the ratio of the Aid recevied (constant 2012 US$) in Small states in 1997 to that in 2003?
Keep it short and to the point. 1.04. What is the ratio of the Aid recevied (constant 2012 US$) in Arab World in 1998 to that in 1999?
Offer a terse response. 0.71. What is the ratio of the Aid recevied (constant 2012 US$) in East Asia (all income levels) in 1998 to that in 1999?
Provide a succinct answer. 4.79. What is the ratio of the Aid recevied (constant 2012 US$) in Small states in 1998 to that in 1999?
Make the answer very short. 1.91. What is the ratio of the Aid recevied (constant 2012 US$) in Arab World in 1998 to that in 2000?
Ensure brevity in your answer.  0.49. What is the ratio of the Aid recevied (constant 2012 US$) in East Asia (all income levels) in 1998 to that in 2000?
Offer a terse response. 0.11. What is the ratio of the Aid recevied (constant 2012 US$) of Small states in 1998 to that in 2000?
Keep it short and to the point. 4.65. What is the ratio of the Aid recevied (constant 2012 US$) of Arab World in 1998 to that in 2001?
Ensure brevity in your answer.  0.64. What is the ratio of the Aid recevied (constant 2012 US$) in East Asia (all income levels) in 1998 to that in 2001?
Your answer should be very brief. 0.11. What is the ratio of the Aid recevied (constant 2012 US$) in Small states in 1998 to that in 2001?
Your answer should be very brief. 2.89. What is the ratio of the Aid recevied (constant 2012 US$) of Arab World in 1998 to that in 2002?
Give a very brief answer. 0.57. What is the ratio of the Aid recevied (constant 2012 US$) of East Asia (all income levels) in 1998 to that in 2002?
Provide a succinct answer. 0.11. What is the ratio of the Aid recevied (constant 2012 US$) of Small states in 1998 to that in 2002?
Provide a succinct answer. 5.69. What is the ratio of the Aid recevied (constant 2012 US$) in Arab World in 1998 to that in 2003?
Offer a very short reply. 0.62. What is the ratio of the Aid recevied (constant 2012 US$) in East Asia (all income levels) in 1998 to that in 2003?
Offer a terse response. 0.17. What is the ratio of the Aid recevied (constant 2012 US$) of Small states in 1998 to that in 2003?
Give a very brief answer. 6.91. What is the ratio of the Aid recevied (constant 2012 US$) of Arab World in 1999 to that in 2000?
Your response must be concise. 0.7. What is the ratio of the Aid recevied (constant 2012 US$) of East Asia (all income levels) in 1999 to that in 2000?
Give a very brief answer. 0.02. What is the ratio of the Aid recevied (constant 2012 US$) in Small states in 1999 to that in 2000?
Ensure brevity in your answer.  2.44. What is the ratio of the Aid recevied (constant 2012 US$) in Arab World in 1999 to that in 2001?
Make the answer very short. 0.9. What is the ratio of the Aid recevied (constant 2012 US$) of East Asia (all income levels) in 1999 to that in 2001?
Your answer should be very brief. 0.02. What is the ratio of the Aid recevied (constant 2012 US$) of Small states in 1999 to that in 2001?
Your response must be concise. 1.51. What is the ratio of the Aid recevied (constant 2012 US$) of Arab World in 1999 to that in 2002?
Your answer should be very brief. 0.81. What is the ratio of the Aid recevied (constant 2012 US$) in East Asia (all income levels) in 1999 to that in 2002?
Keep it short and to the point. 0.02. What is the ratio of the Aid recevied (constant 2012 US$) of Small states in 1999 to that in 2002?
Give a very brief answer. 2.98. What is the ratio of the Aid recevied (constant 2012 US$) of Arab World in 1999 to that in 2003?
Your answer should be compact. 0.87. What is the ratio of the Aid recevied (constant 2012 US$) in East Asia (all income levels) in 1999 to that in 2003?
Your response must be concise. 0.03. What is the ratio of the Aid recevied (constant 2012 US$) of Small states in 1999 to that in 2003?
Offer a terse response. 3.62. What is the ratio of the Aid recevied (constant 2012 US$) of Arab World in 2000 to that in 2001?
Offer a very short reply. 1.29. What is the ratio of the Aid recevied (constant 2012 US$) in East Asia (all income levels) in 2000 to that in 2001?
Your answer should be very brief. 1.03. What is the ratio of the Aid recevied (constant 2012 US$) of Small states in 2000 to that in 2001?
Your response must be concise. 0.62. What is the ratio of the Aid recevied (constant 2012 US$) in Arab World in 2000 to that in 2002?
Your answer should be very brief. 1.16. What is the ratio of the Aid recevied (constant 2012 US$) in East Asia (all income levels) in 2000 to that in 2002?
Offer a terse response. 0.98. What is the ratio of the Aid recevied (constant 2012 US$) in Small states in 2000 to that in 2002?
Offer a very short reply. 1.22. What is the ratio of the Aid recevied (constant 2012 US$) in Arab World in 2000 to that in 2003?
Your response must be concise. 1.26. What is the ratio of the Aid recevied (constant 2012 US$) in East Asia (all income levels) in 2000 to that in 2003?
Ensure brevity in your answer.  1.52. What is the ratio of the Aid recevied (constant 2012 US$) in Small states in 2000 to that in 2003?
Provide a succinct answer. 1.49. What is the ratio of the Aid recevied (constant 2012 US$) in Arab World in 2001 to that in 2002?
Ensure brevity in your answer.  0.9. What is the ratio of the Aid recevied (constant 2012 US$) of East Asia (all income levels) in 2001 to that in 2002?
Provide a succinct answer. 0.95. What is the ratio of the Aid recevied (constant 2012 US$) in Small states in 2001 to that in 2002?
Offer a terse response. 1.97. What is the ratio of the Aid recevied (constant 2012 US$) in Arab World in 2001 to that in 2003?
Provide a succinct answer. 0.97. What is the ratio of the Aid recevied (constant 2012 US$) of East Asia (all income levels) in 2001 to that in 2003?
Your answer should be compact. 1.48. What is the ratio of the Aid recevied (constant 2012 US$) of Small states in 2001 to that in 2003?
Give a very brief answer. 2.39. What is the ratio of the Aid recevied (constant 2012 US$) of Arab World in 2002 to that in 2003?
Ensure brevity in your answer.  1.08. What is the ratio of the Aid recevied (constant 2012 US$) of East Asia (all income levels) in 2002 to that in 2003?
Ensure brevity in your answer.  1.55. What is the ratio of the Aid recevied (constant 2012 US$) of Small states in 2002 to that in 2003?
Ensure brevity in your answer.  1.21. What is the difference between the highest and the second highest Aid recevied (constant 2012 US$) of Arab World?
Keep it short and to the point. 6.77e+06. What is the difference between the highest and the second highest Aid recevied (constant 2012 US$) in East Asia (all income levels)?
Your response must be concise. 2.23e+07. What is the difference between the highest and the second highest Aid recevied (constant 2012 US$) of Small states?
Offer a very short reply. 1.57e+07. What is the difference between the highest and the lowest Aid recevied (constant 2012 US$) in Arab World?
Give a very brief answer. 3.78e+07. What is the difference between the highest and the lowest Aid recevied (constant 2012 US$) in East Asia (all income levels)?
Keep it short and to the point. 1.11e+09. What is the difference between the highest and the lowest Aid recevied (constant 2012 US$) of Small states?
Your response must be concise. 3.09e+07. 